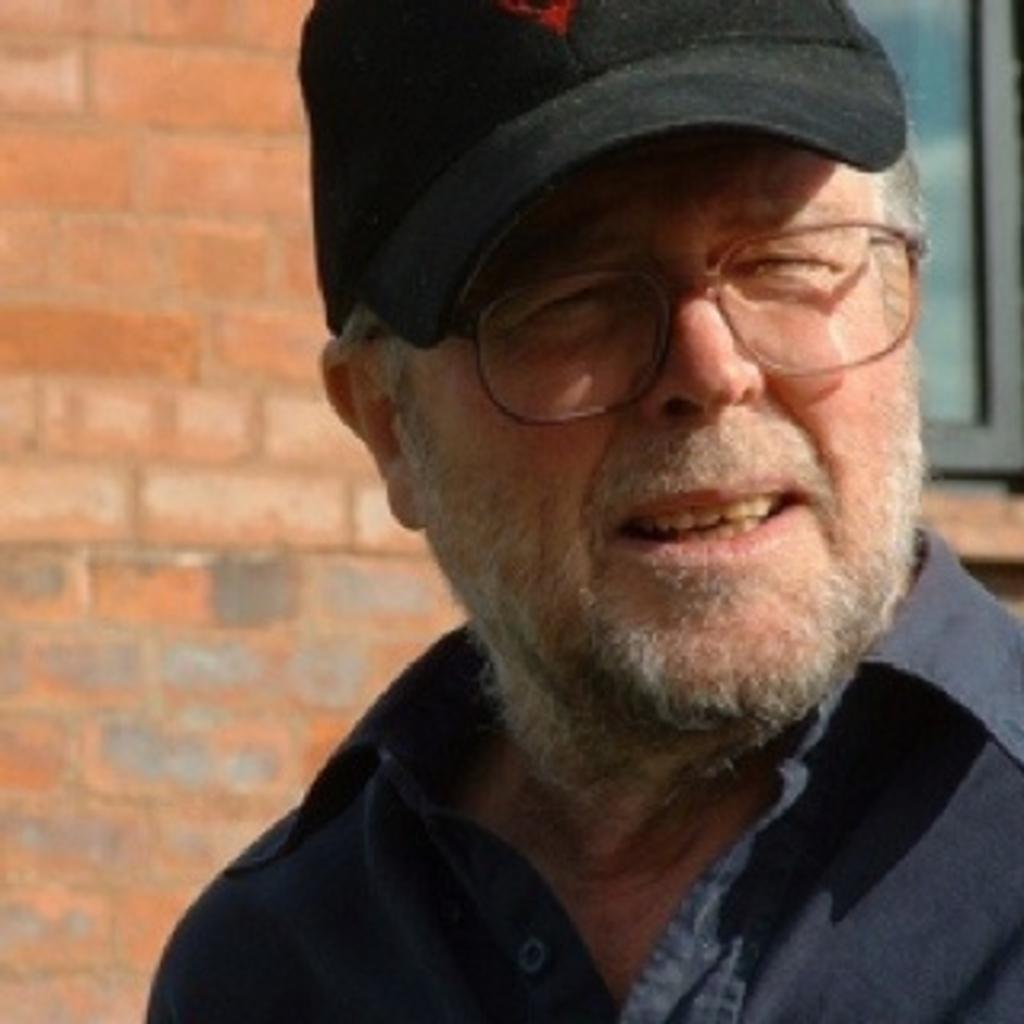What is the main subject in the foreground of the image? There is a person in the foreground of the image. What accessories is the person wearing? The person is wearing a hat and spectacles. What can be seen in the background of the image? There is a wall and a window in the background of the image. What type of stew can be seen simmering on the stove in the image? There is no stove or stew present in the image; it features a person in the foreground and a wall and window in the background. How does the person in the image demonstrate their learning abilities? The image does not show the person's learning abilities or any indication of learning; it only shows the person wearing a hat and spectacles in the foreground. 